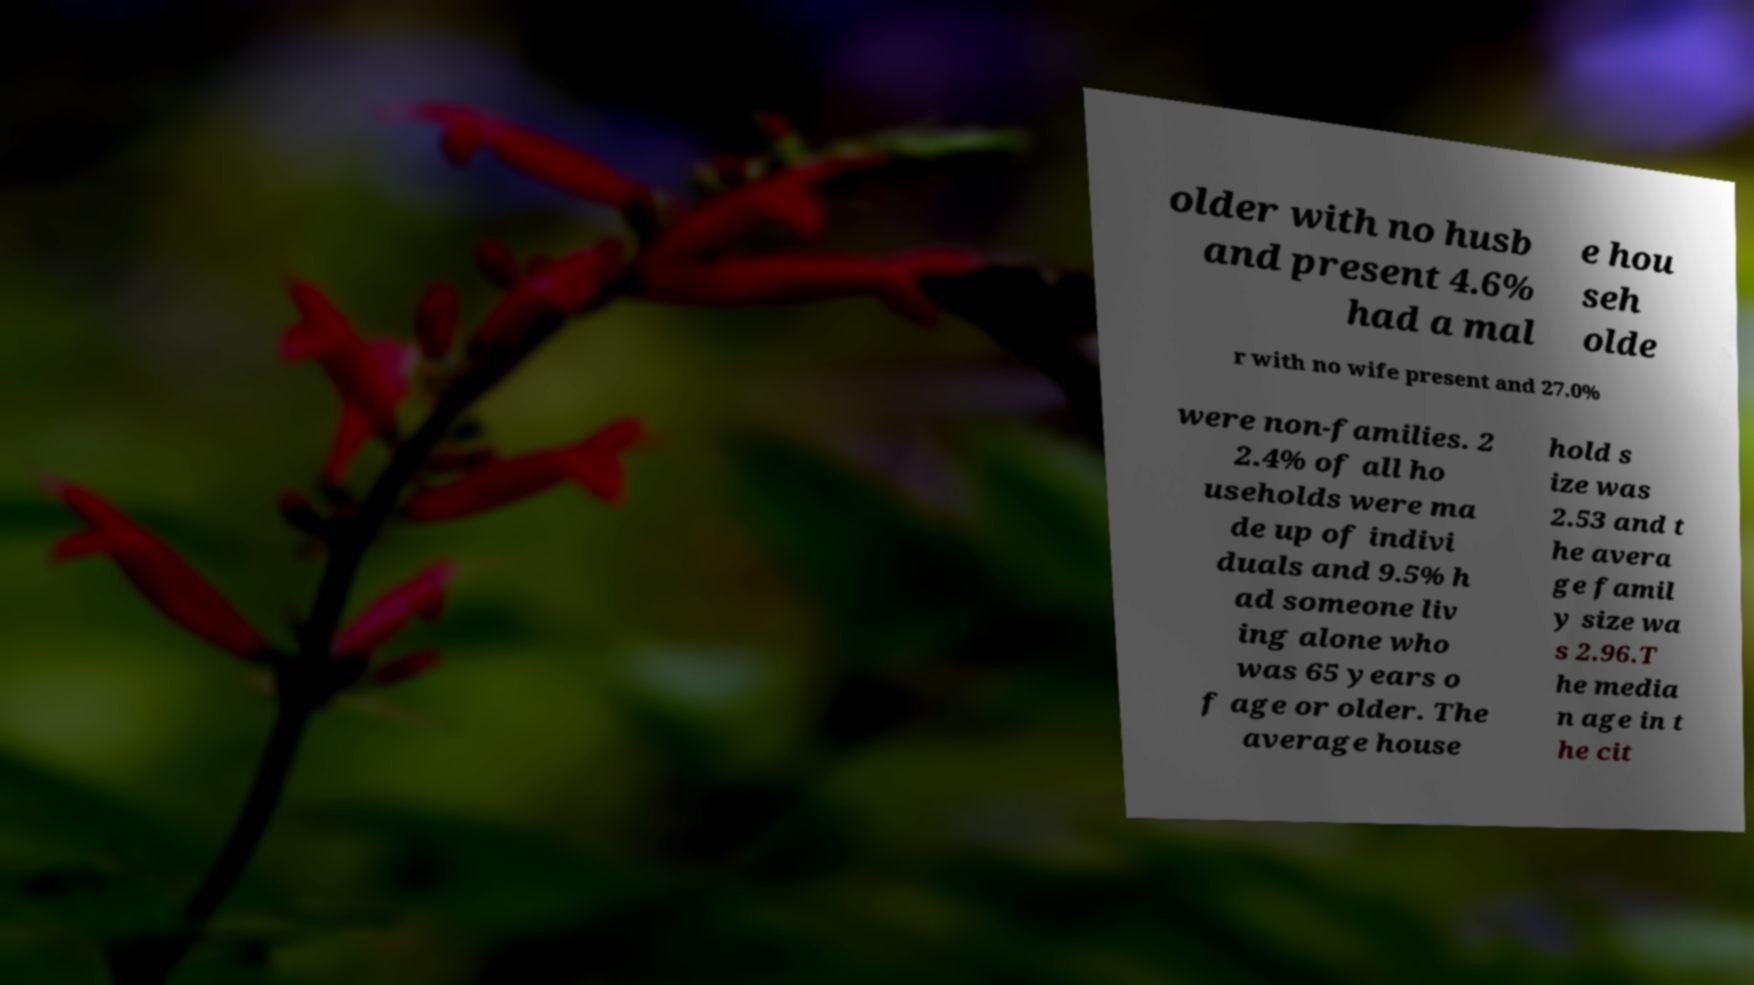What messages or text are displayed in this image? I need them in a readable, typed format. older with no husb and present 4.6% had a mal e hou seh olde r with no wife present and 27.0% were non-families. 2 2.4% of all ho useholds were ma de up of indivi duals and 9.5% h ad someone liv ing alone who was 65 years o f age or older. The average house hold s ize was 2.53 and t he avera ge famil y size wa s 2.96.T he media n age in t he cit 